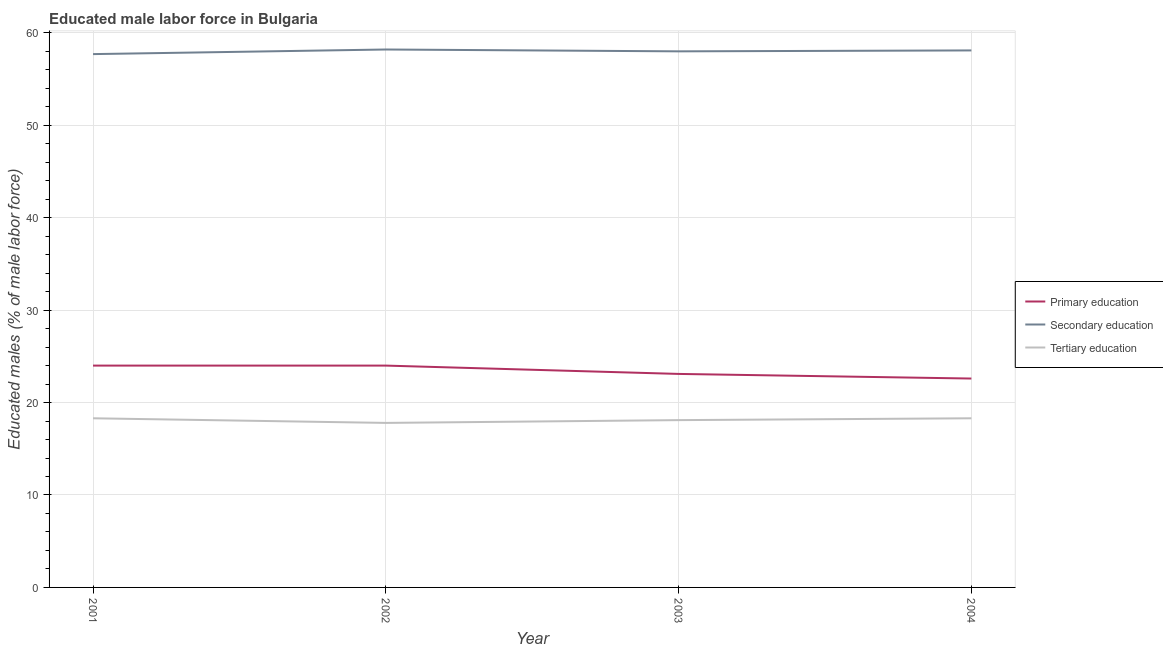What is the percentage of male labor force who received secondary education in 2001?
Provide a short and direct response. 57.7. Across all years, what is the maximum percentage of male labor force who received tertiary education?
Make the answer very short. 18.3. Across all years, what is the minimum percentage of male labor force who received primary education?
Keep it short and to the point. 22.6. What is the total percentage of male labor force who received secondary education in the graph?
Your answer should be very brief. 232. What is the difference between the percentage of male labor force who received primary education in 2002 and that in 2004?
Your response must be concise. 1.4. What is the difference between the percentage of male labor force who received primary education in 2001 and the percentage of male labor force who received secondary education in 2003?
Offer a terse response. -34. What is the average percentage of male labor force who received primary education per year?
Keep it short and to the point. 23.43. In the year 2004, what is the difference between the percentage of male labor force who received primary education and percentage of male labor force who received tertiary education?
Give a very brief answer. 4.3. What is the ratio of the percentage of male labor force who received secondary education in 2002 to that in 2004?
Provide a short and direct response. 1. Is the difference between the percentage of male labor force who received primary education in 2002 and 2004 greater than the difference between the percentage of male labor force who received tertiary education in 2002 and 2004?
Offer a terse response. Yes. What is the difference between the highest and the second highest percentage of male labor force who received secondary education?
Give a very brief answer. 0.1. What is the difference between the highest and the lowest percentage of male labor force who received primary education?
Offer a very short reply. 1.4. In how many years, is the percentage of male labor force who received tertiary education greater than the average percentage of male labor force who received tertiary education taken over all years?
Offer a terse response. 2. Is it the case that in every year, the sum of the percentage of male labor force who received primary education and percentage of male labor force who received secondary education is greater than the percentage of male labor force who received tertiary education?
Your answer should be very brief. Yes. Does the percentage of male labor force who received primary education monotonically increase over the years?
Make the answer very short. No. Is the percentage of male labor force who received secondary education strictly greater than the percentage of male labor force who received tertiary education over the years?
Ensure brevity in your answer.  Yes. What is the difference between two consecutive major ticks on the Y-axis?
Make the answer very short. 10. Are the values on the major ticks of Y-axis written in scientific E-notation?
Provide a succinct answer. No. How many legend labels are there?
Your response must be concise. 3. What is the title of the graph?
Your response must be concise. Educated male labor force in Bulgaria. Does "Agricultural raw materials" appear as one of the legend labels in the graph?
Offer a terse response. No. What is the label or title of the X-axis?
Make the answer very short. Year. What is the label or title of the Y-axis?
Provide a short and direct response. Educated males (% of male labor force). What is the Educated males (% of male labor force) in Secondary education in 2001?
Provide a succinct answer. 57.7. What is the Educated males (% of male labor force) in Tertiary education in 2001?
Your answer should be compact. 18.3. What is the Educated males (% of male labor force) of Primary education in 2002?
Ensure brevity in your answer.  24. What is the Educated males (% of male labor force) of Secondary education in 2002?
Offer a very short reply. 58.2. What is the Educated males (% of male labor force) in Tertiary education in 2002?
Your answer should be compact. 17.8. What is the Educated males (% of male labor force) in Primary education in 2003?
Your answer should be compact. 23.1. What is the Educated males (% of male labor force) in Tertiary education in 2003?
Give a very brief answer. 18.1. What is the Educated males (% of male labor force) in Primary education in 2004?
Keep it short and to the point. 22.6. What is the Educated males (% of male labor force) in Secondary education in 2004?
Ensure brevity in your answer.  58.1. What is the Educated males (% of male labor force) in Tertiary education in 2004?
Offer a terse response. 18.3. Across all years, what is the maximum Educated males (% of male labor force) in Primary education?
Offer a terse response. 24. Across all years, what is the maximum Educated males (% of male labor force) in Secondary education?
Provide a short and direct response. 58.2. Across all years, what is the maximum Educated males (% of male labor force) of Tertiary education?
Provide a succinct answer. 18.3. Across all years, what is the minimum Educated males (% of male labor force) in Primary education?
Provide a short and direct response. 22.6. Across all years, what is the minimum Educated males (% of male labor force) in Secondary education?
Your answer should be compact. 57.7. Across all years, what is the minimum Educated males (% of male labor force) of Tertiary education?
Ensure brevity in your answer.  17.8. What is the total Educated males (% of male labor force) of Primary education in the graph?
Provide a succinct answer. 93.7. What is the total Educated males (% of male labor force) in Secondary education in the graph?
Make the answer very short. 232. What is the total Educated males (% of male labor force) in Tertiary education in the graph?
Keep it short and to the point. 72.5. What is the difference between the Educated males (% of male labor force) of Primary education in 2001 and that in 2003?
Offer a terse response. 0.9. What is the difference between the Educated males (% of male labor force) in Tertiary education in 2001 and that in 2003?
Provide a succinct answer. 0.2. What is the difference between the Educated males (% of male labor force) of Secondary education in 2001 and that in 2004?
Your answer should be compact. -0.4. What is the difference between the Educated males (% of male labor force) of Primary education in 2002 and that in 2003?
Your answer should be very brief. 0.9. What is the difference between the Educated males (% of male labor force) in Primary education in 2001 and the Educated males (% of male labor force) in Secondary education in 2002?
Offer a terse response. -34.2. What is the difference between the Educated males (% of male labor force) in Secondary education in 2001 and the Educated males (% of male labor force) in Tertiary education in 2002?
Ensure brevity in your answer.  39.9. What is the difference between the Educated males (% of male labor force) of Primary education in 2001 and the Educated males (% of male labor force) of Secondary education in 2003?
Keep it short and to the point. -34. What is the difference between the Educated males (% of male labor force) of Secondary education in 2001 and the Educated males (% of male labor force) of Tertiary education in 2003?
Keep it short and to the point. 39.6. What is the difference between the Educated males (% of male labor force) of Primary education in 2001 and the Educated males (% of male labor force) of Secondary education in 2004?
Give a very brief answer. -34.1. What is the difference between the Educated males (% of male labor force) of Primary education in 2001 and the Educated males (% of male labor force) of Tertiary education in 2004?
Your answer should be compact. 5.7. What is the difference between the Educated males (% of male labor force) of Secondary education in 2001 and the Educated males (% of male labor force) of Tertiary education in 2004?
Give a very brief answer. 39.4. What is the difference between the Educated males (% of male labor force) in Primary education in 2002 and the Educated males (% of male labor force) in Secondary education in 2003?
Provide a succinct answer. -34. What is the difference between the Educated males (% of male labor force) of Primary education in 2002 and the Educated males (% of male labor force) of Tertiary education in 2003?
Offer a terse response. 5.9. What is the difference between the Educated males (% of male labor force) of Secondary education in 2002 and the Educated males (% of male labor force) of Tertiary education in 2003?
Offer a very short reply. 40.1. What is the difference between the Educated males (% of male labor force) of Primary education in 2002 and the Educated males (% of male labor force) of Secondary education in 2004?
Your answer should be very brief. -34.1. What is the difference between the Educated males (% of male labor force) in Secondary education in 2002 and the Educated males (% of male labor force) in Tertiary education in 2004?
Give a very brief answer. 39.9. What is the difference between the Educated males (% of male labor force) in Primary education in 2003 and the Educated males (% of male labor force) in Secondary education in 2004?
Your answer should be compact. -35. What is the difference between the Educated males (% of male labor force) of Secondary education in 2003 and the Educated males (% of male labor force) of Tertiary education in 2004?
Your response must be concise. 39.7. What is the average Educated males (% of male labor force) of Primary education per year?
Offer a very short reply. 23.43. What is the average Educated males (% of male labor force) of Tertiary education per year?
Offer a terse response. 18.12. In the year 2001, what is the difference between the Educated males (% of male labor force) in Primary education and Educated males (% of male labor force) in Secondary education?
Your answer should be compact. -33.7. In the year 2001, what is the difference between the Educated males (% of male labor force) of Secondary education and Educated males (% of male labor force) of Tertiary education?
Your answer should be very brief. 39.4. In the year 2002, what is the difference between the Educated males (% of male labor force) in Primary education and Educated males (% of male labor force) in Secondary education?
Your answer should be compact. -34.2. In the year 2002, what is the difference between the Educated males (% of male labor force) of Secondary education and Educated males (% of male labor force) of Tertiary education?
Your answer should be compact. 40.4. In the year 2003, what is the difference between the Educated males (% of male labor force) of Primary education and Educated males (% of male labor force) of Secondary education?
Keep it short and to the point. -34.9. In the year 2003, what is the difference between the Educated males (% of male labor force) of Secondary education and Educated males (% of male labor force) of Tertiary education?
Offer a very short reply. 39.9. In the year 2004, what is the difference between the Educated males (% of male labor force) of Primary education and Educated males (% of male labor force) of Secondary education?
Give a very brief answer. -35.5. In the year 2004, what is the difference between the Educated males (% of male labor force) of Secondary education and Educated males (% of male labor force) of Tertiary education?
Your answer should be compact. 39.8. What is the ratio of the Educated males (% of male labor force) in Secondary education in 2001 to that in 2002?
Keep it short and to the point. 0.99. What is the ratio of the Educated males (% of male labor force) in Tertiary education in 2001 to that in 2002?
Keep it short and to the point. 1.03. What is the ratio of the Educated males (% of male labor force) in Primary education in 2001 to that in 2003?
Provide a succinct answer. 1.04. What is the ratio of the Educated males (% of male labor force) of Secondary education in 2001 to that in 2003?
Offer a terse response. 0.99. What is the ratio of the Educated males (% of male labor force) of Tertiary education in 2001 to that in 2003?
Ensure brevity in your answer.  1.01. What is the ratio of the Educated males (% of male labor force) of Primary education in 2001 to that in 2004?
Make the answer very short. 1.06. What is the ratio of the Educated males (% of male labor force) in Secondary education in 2001 to that in 2004?
Offer a very short reply. 0.99. What is the ratio of the Educated males (% of male labor force) in Tertiary education in 2001 to that in 2004?
Your answer should be very brief. 1. What is the ratio of the Educated males (% of male labor force) of Primary education in 2002 to that in 2003?
Offer a terse response. 1.04. What is the ratio of the Educated males (% of male labor force) of Tertiary education in 2002 to that in 2003?
Give a very brief answer. 0.98. What is the ratio of the Educated males (% of male labor force) in Primary education in 2002 to that in 2004?
Make the answer very short. 1.06. What is the ratio of the Educated males (% of male labor force) in Secondary education in 2002 to that in 2004?
Give a very brief answer. 1. What is the ratio of the Educated males (% of male labor force) in Tertiary education in 2002 to that in 2004?
Your answer should be compact. 0.97. What is the ratio of the Educated males (% of male labor force) in Primary education in 2003 to that in 2004?
Your response must be concise. 1.02. What is the ratio of the Educated males (% of male labor force) in Tertiary education in 2003 to that in 2004?
Ensure brevity in your answer.  0.99. What is the difference between the highest and the second highest Educated males (% of male labor force) of Primary education?
Your answer should be very brief. 0. What is the difference between the highest and the second highest Educated males (% of male labor force) of Secondary education?
Offer a very short reply. 0.1. What is the difference between the highest and the second highest Educated males (% of male labor force) in Tertiary education?
Make the answer very short. 0. 